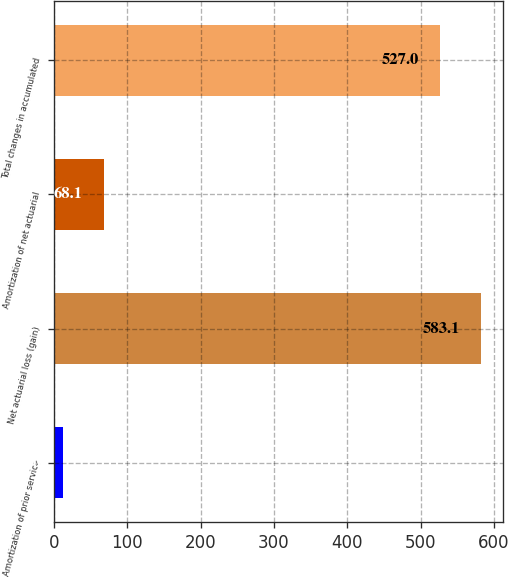<chart> <loc_0><loc_0><loc_500><loc_500><bar_chart><fcel>Amortization of prior service<fcel>Net actuarial loss (gain)<fcel>Amortization of net actuarial<fcel>Total changes in accumulated<nl><fcel>12<fcel>583.1<fcel>68.1<fcel>527<nl></chart> 